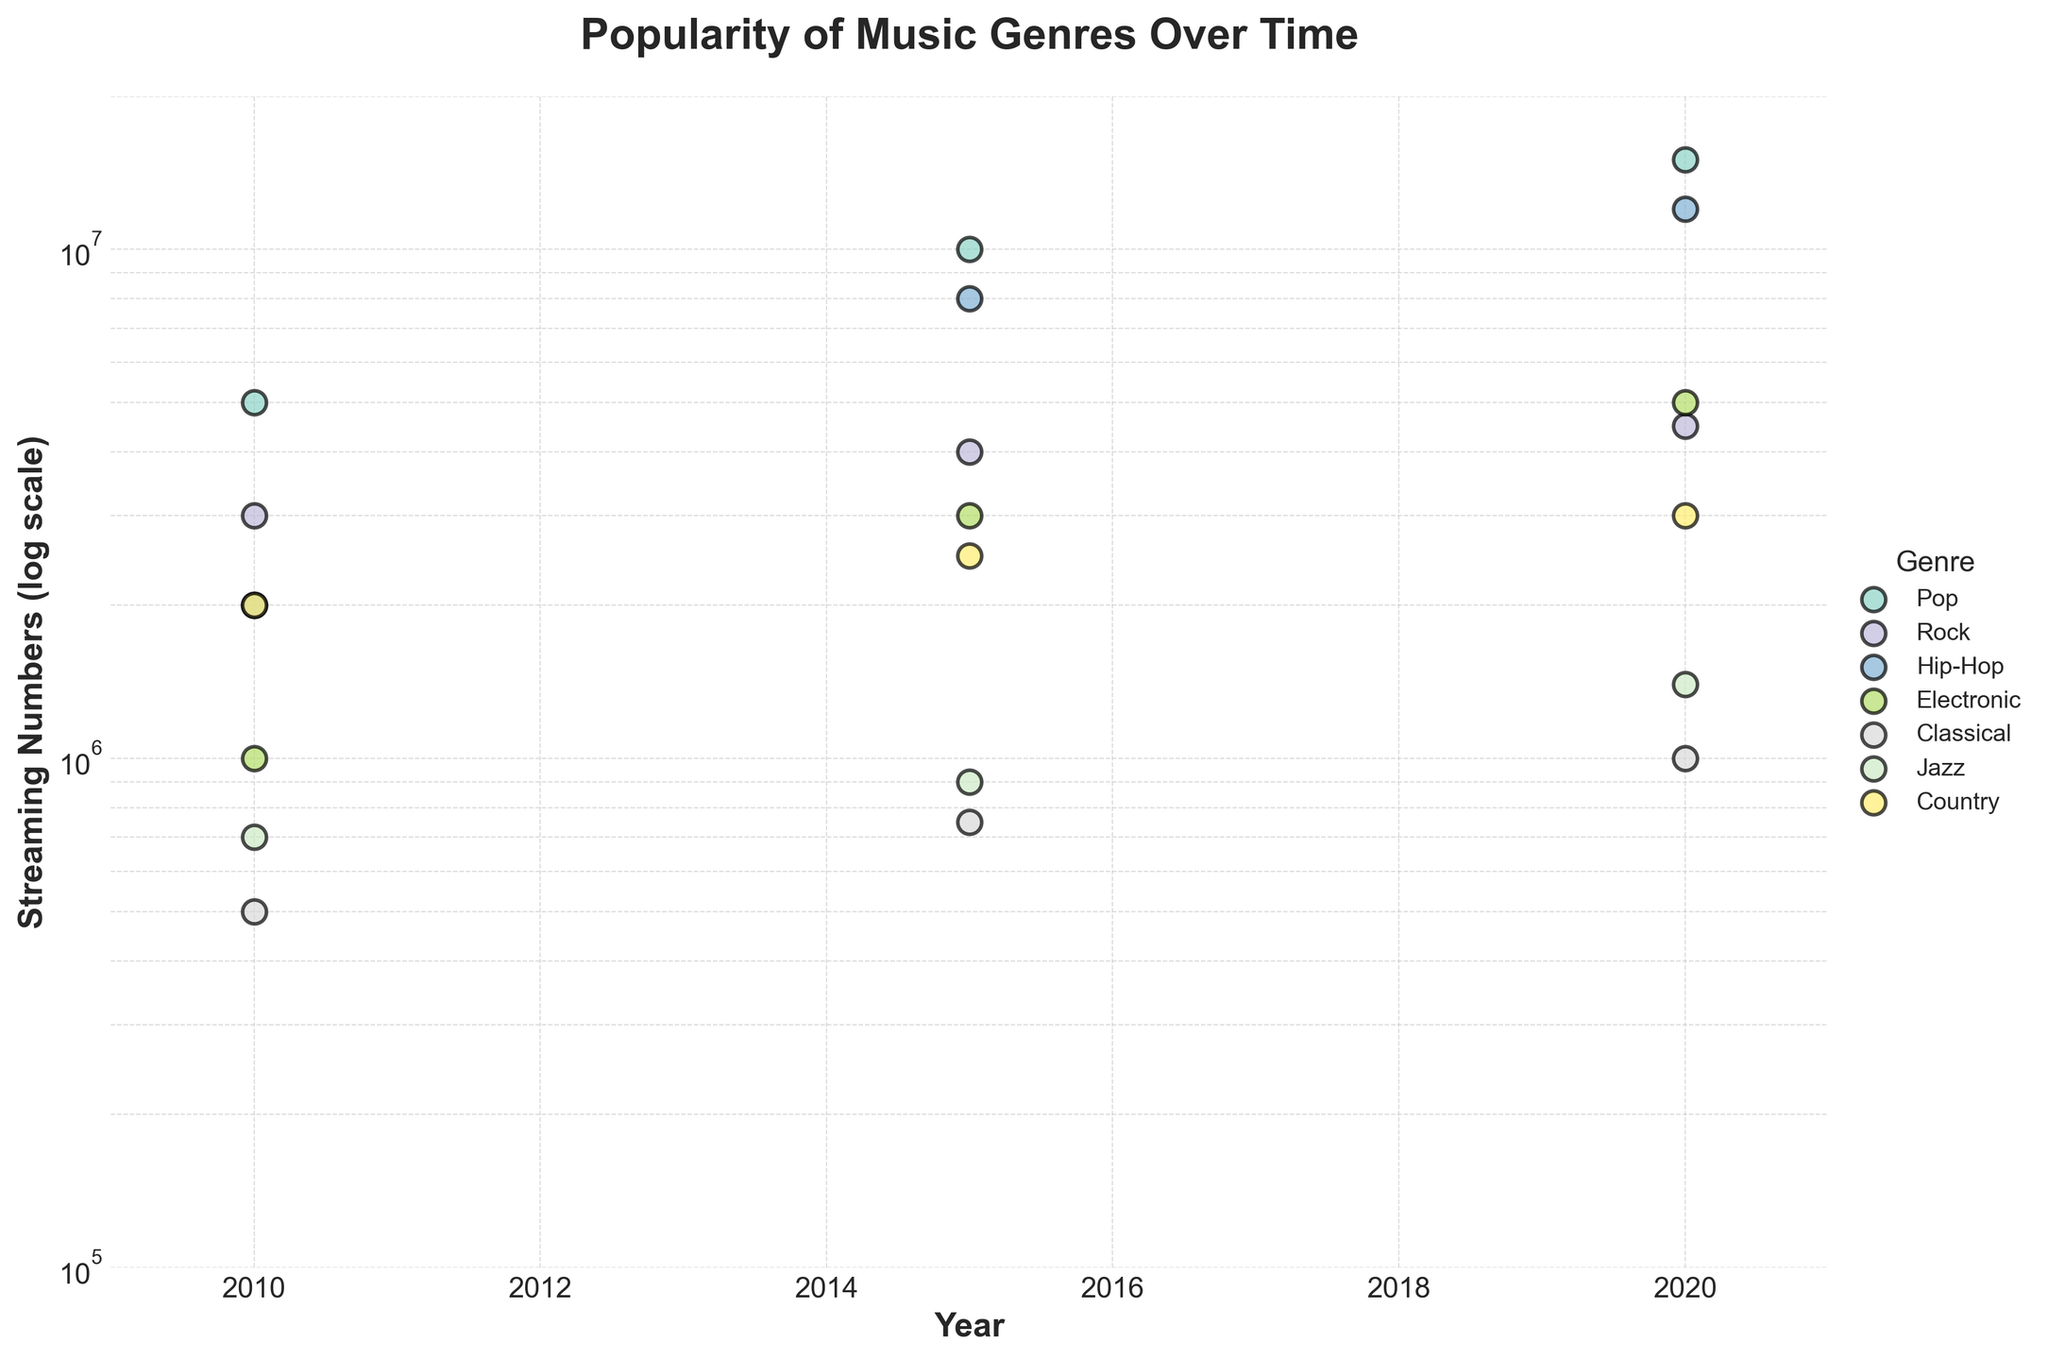what is the title of the plot? The title of the plot is displayed at the top center of the plot. It is written in bold font.
Answer: Popularity of Music Genres Over Time Which genre has the highest streaming numbers in 2020? Look for the highest point on the y-axis for the year 2020. Identify the genre associated with this point.
Answer: Pop How did the streaming numbers for Hip-Hop change from 2010 to 2020? Check the y-values for Hip-Hop in 2010 and 2020. The streaming numbers increased from 2,000,000 in 2010 to 12,000,000 in 2020.
Answer: It increased Which genre had the least increase in streaming numbers from 2010 to 2020? Compare the y-values for each genre in 2010 and 2020 and find the smallest difference.
Answer: Classical Compare the streaming numbers of Pop and Rock in 2015. Which is higher? Find the y-values for Pop and Rock in 2015. Pop is at 10,000,000 and Rock is at 4,000,000. Pop’s value is higher.
Answer: Pop What is the streaming number for Jazz in 2015? Locate the point corresponding to Jazz for the year 2015 on the x-axis. Read the y-value from the log scale.
Answer: 900,000 Which genre shows the most consistent growth in streaming numbers over the years 2010 to 2020? Check the genre whose points form a straight line trend on the log scale, indicating consistent growth.
Answer: Pop Compare the growth between Hip-Hop and Electronic from 2010 to 2020. Which genre experienced higher growth? Calculate the difference in y-values for Hip-Hop (12,000,000 - 2,000,000) and Electronic (5,000,000 - 1,000,000). Hip-Hop: 10,000,000, Electronic: 4,000,000. Hip-Hop experienced higher growth.
Answer: Hip-Hop Excluding 2020, which genre had the highest streaming numbers in the plot? Look at the highest y-values across the years excluding 2020. Identify the genre associated with this point.
Answer: Pop 